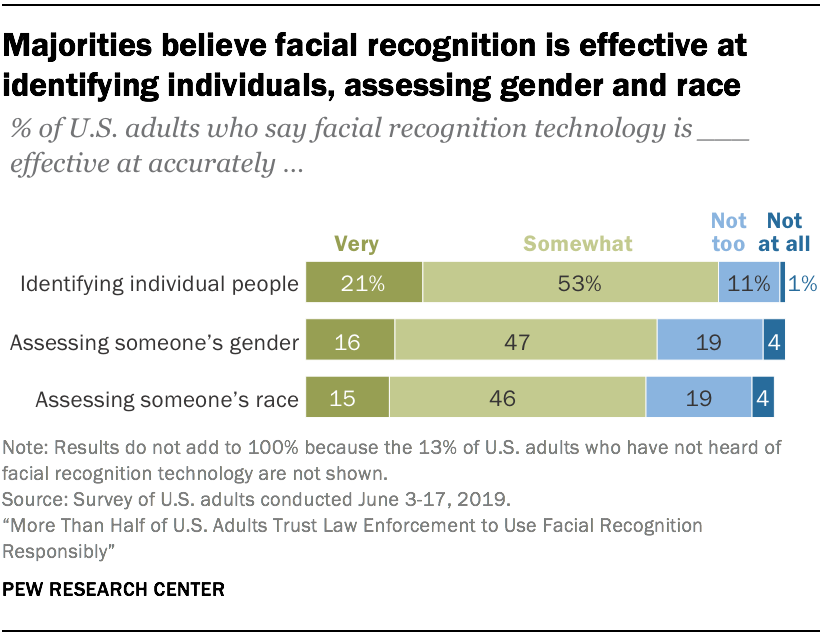Give some essential details in this illustration. The sum of the last two bottom bars is approximately 93. According to the top bar, approximately 53% of respondents answered "somewhat" to the question "How likely are you to recommend our product to a friend or colleague? 